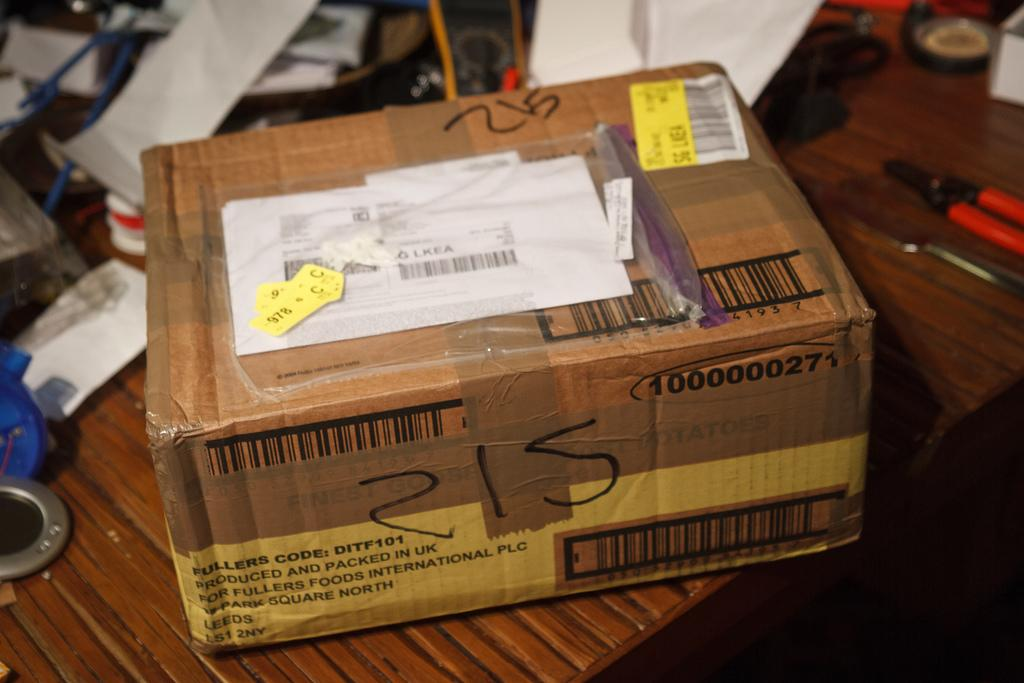<image>
Present a compact description of the photo's key features. A brown cardboard box that was produced and packaged in the UK. 